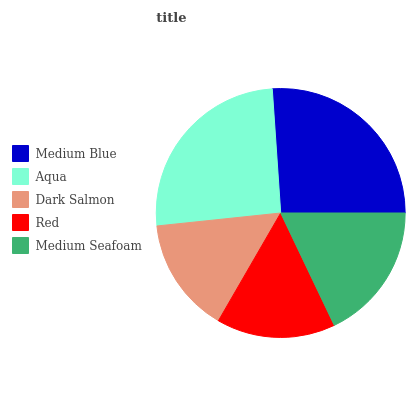Is Dark Salmon the minimum?
Answer yes or no. Yes. Is Medium Blue the maximum?
Answer yes or no. Yes. Is Aqua the minimum?
Answer yes or no. No. Is Aqua the maximum?
Answer yes or no. No. Is Medium Blue greater than Aqua?
Answer yes or no. Yes. Is Aqua less than Medium Blue?
Answer yes or no. Yes. Is Aqua greater than Medium Blue?
Answer yes or no. No. Is Medium Blue less than Aqua?
Answer yes or no. No. Is Medium Seafoam the high median?
Answer yes or no. Yes. Is Medium Seafoam the low median?
Answer yes or no. Yes. Is Dark Salmon the high median?
Answer yes or no. No. Is Aqua the low median?
Answer yes or no. No. 